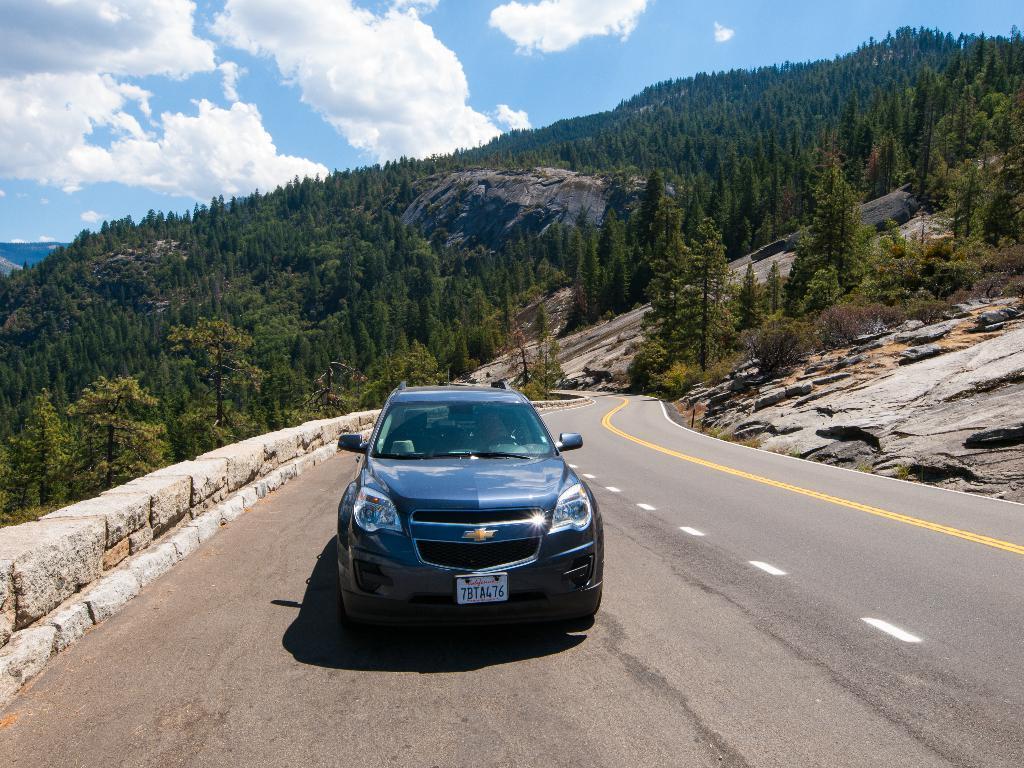Describe this image in one or two sentences. In this image we can see there are trees, plants. There is a car and a road. In the background we can see cloudy sky.   